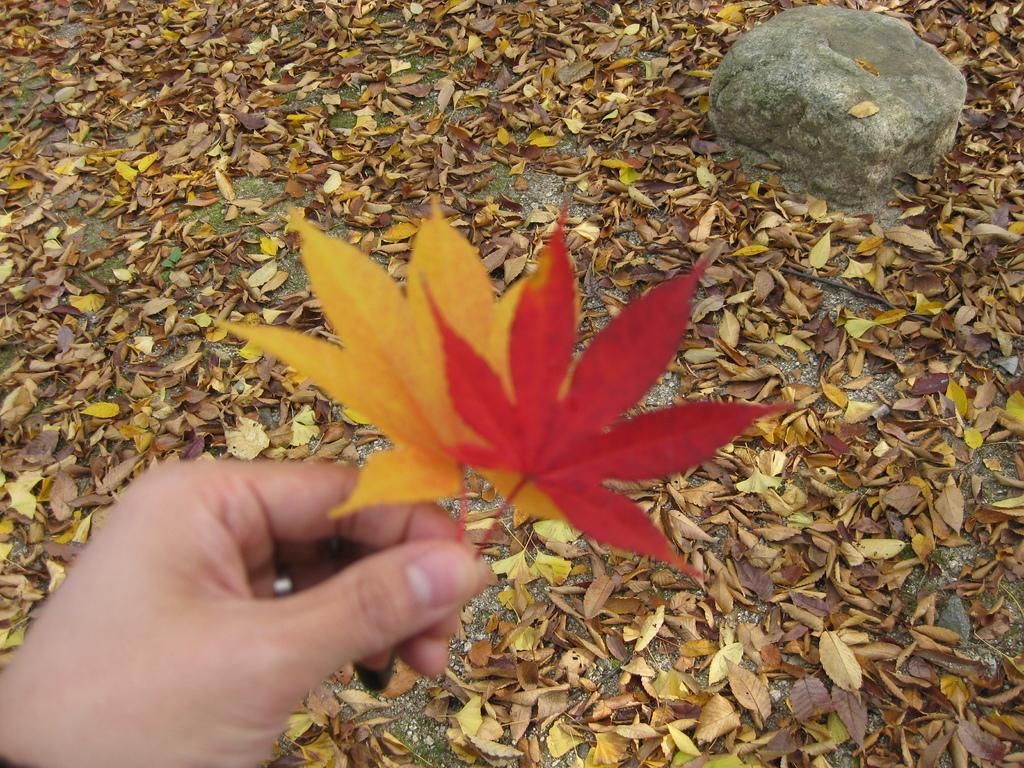What is the person's hand holding in the image? The person's hand is holding leaves in the image. What other object can be seen in the image? There is a rock in the image. What can be observed in the background of the image? In the background, there are shredded leaves on the ground. What type of punishment is being administered to the leaves in the image? There is no punishment being administered to the leaves in the image; the person's hand is simply holding them. 